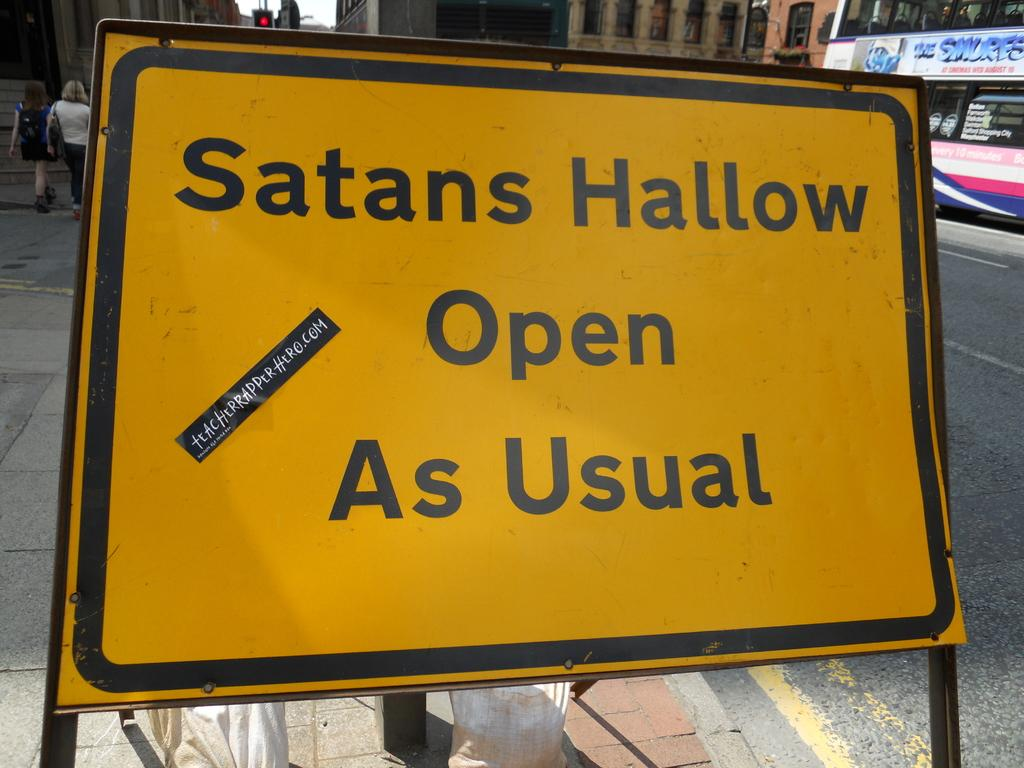Provide a one-sentence caption for the provided image. A yellow sign that says Satans Hallow Open As Usual. 